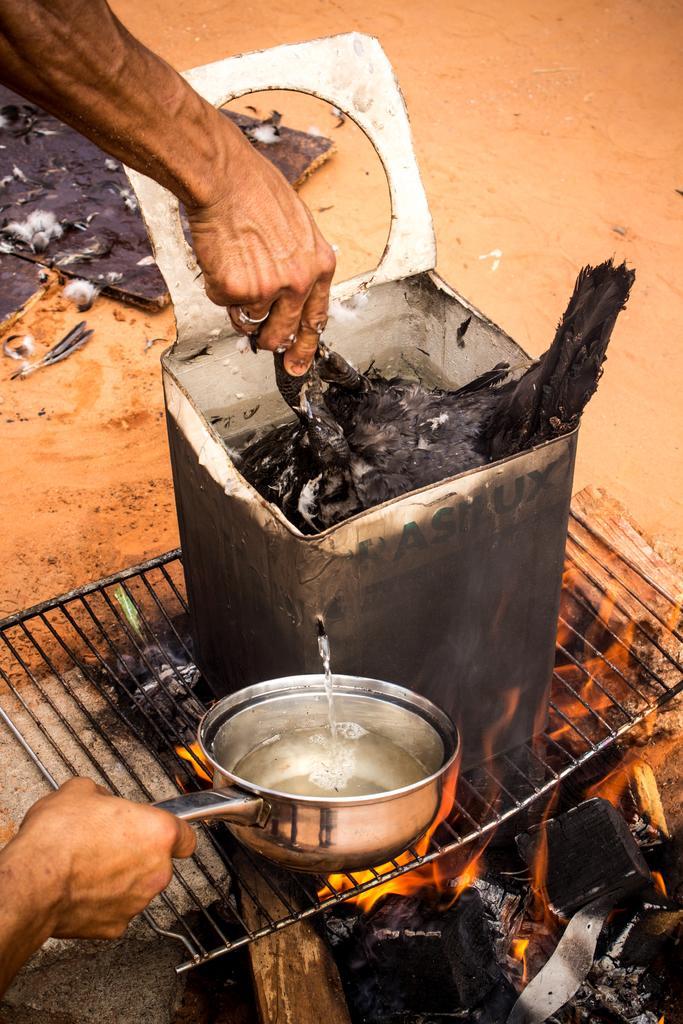In one or two sentences, can you explain what this image depicts? In the image we can see a container, wood, charcoal, fire, sand, finger ring, stone, grill net and human hands. 